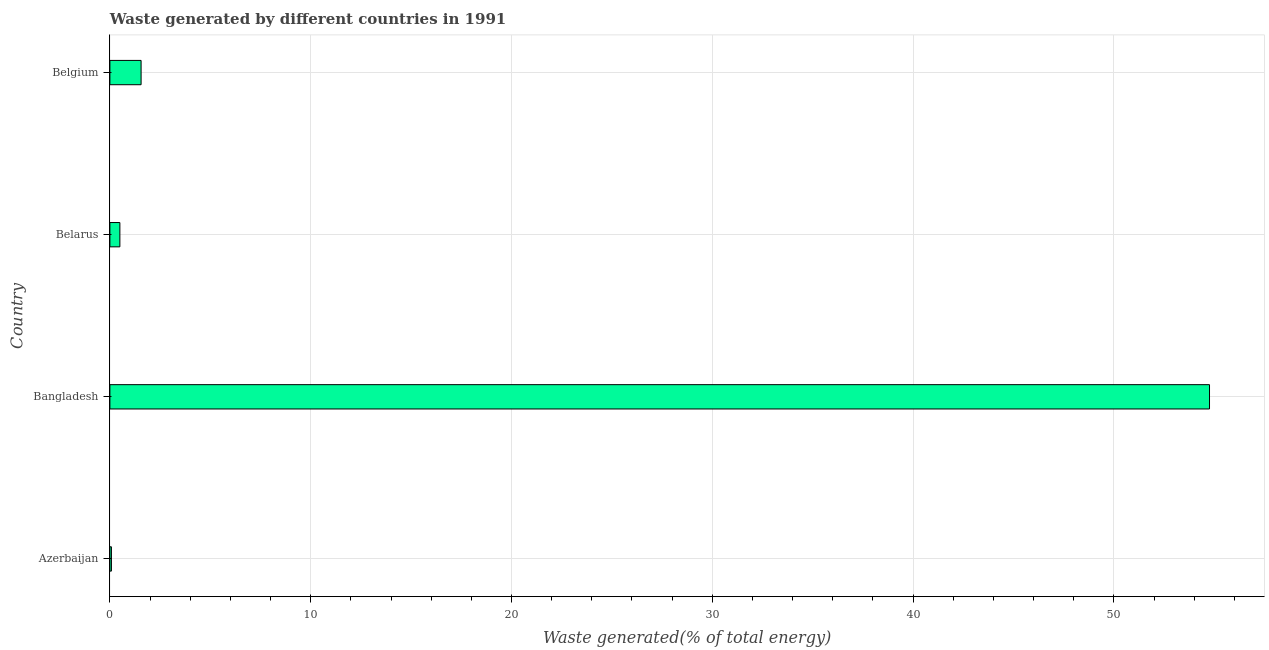Does the graph contain any zero values?
Your answer should be very brief. No. Does the graph contain grids?
Keep it short and to the point. Yes. What is the title of the graph?
Provide a succinct answer. Waste generated by different countries in 1991. What is the label or title of the X-axis?
Offer a terse response. Waste generated(% of total energy). What is the amount of waste generated in Azerbaijan?
Give a very brief answer. 0.08. Across all countries, what is the maximum amount of waste generated?
Provide a short and direct response. 54.76. Across all countries, what is the minimum amount of waste generated?
Offer a terse response. 0.08. In which country was the amount of waste generated minimum?
Your answer should be very brief. Azerbaijan. What is the sum of the amount of waste generated?
Ensure brevity in your answer.  56.89. What is the difference between the amount of waste generated in Azerbaijan and Belgium?
Your answer should be very brief. -1.48. What is the average amount of waste generated per country?
Give a very brief answer. 14.22. What is the median amount of waste generated?
Your response must be concise. 1.03. In how many countries, is the amount of waste generated greater than 50 %?
Offer a very short reply. 1. What is the difference between the highest and the second highest amount of waste generated?
Provide a succinct answer. 53.21. What is the difference between the highest and the lowest amount of waste generated?
Your answer should be compact. 54.69. How many bars are there?
Offer a terse response. 4. Are all the bars in the graph horizontal?
Your answer should be compact. Yes. What is the Waste generated(% of total energy) in Azerbaijan?
Your answer should be compact. 0.08. What is the Waste generated(% of total energy) of Bangladesh?
Keep it short and to the point. 54.76. What is the Waste generated(% of total energy) in Belarus?
Provide a short and direct response. 0.5. What is the Waste generated(% of total energy) of Belgium?
Provide a succinct answer. 1.55. What is the difference between the Waste generated(% of total energy) in Azerbaijan and Bangladesh?
Your answer should be compact. -54.69. What is the difference between the Waste generated(% of total energy) in Azerbaijan and Belarus?
Your response must be concise. -0.42. What is the difference between the Waste generated(% of total energy) in Azerbaijan and Belgium?
Give a very brief answer. -1.48. What is the difference between the Waste generated(% of total energy) in Bangladesh and Belarus?
Your answer should be compact. 54.27. What is the difference between the Waste generated(% of total energy) in Bangladesh and Belgium?
Keep it short and to the point. 53.21. What is the difference between the Waste generated(% of total energy) in Belarus and Belgium?
Keep it short and to the point. -1.06. What is the ratio of the Waste generated(% of total energy) in Azerbaijan to that in Belarus?
Your response must be concise. 0.15. What is the ratio of the Waste generated(% of total energy) in Azerbaijan to that in Belgium?
Your answer should be very brief. 0.05. What is the ratio of the Waste generated(% of total energy) in Bangladesh to that in Belarus?
Your answer should be very brief. 110.21. What is the ratio of the Waste generated(% of total energy) in Bangladesh to that in Belgium?
Your answer should be compact. 35.24. What is the ratio of the Waste generated(% of total energy) in Belarus to that in Belgium?
Keep it short and to the point. 0.32. 